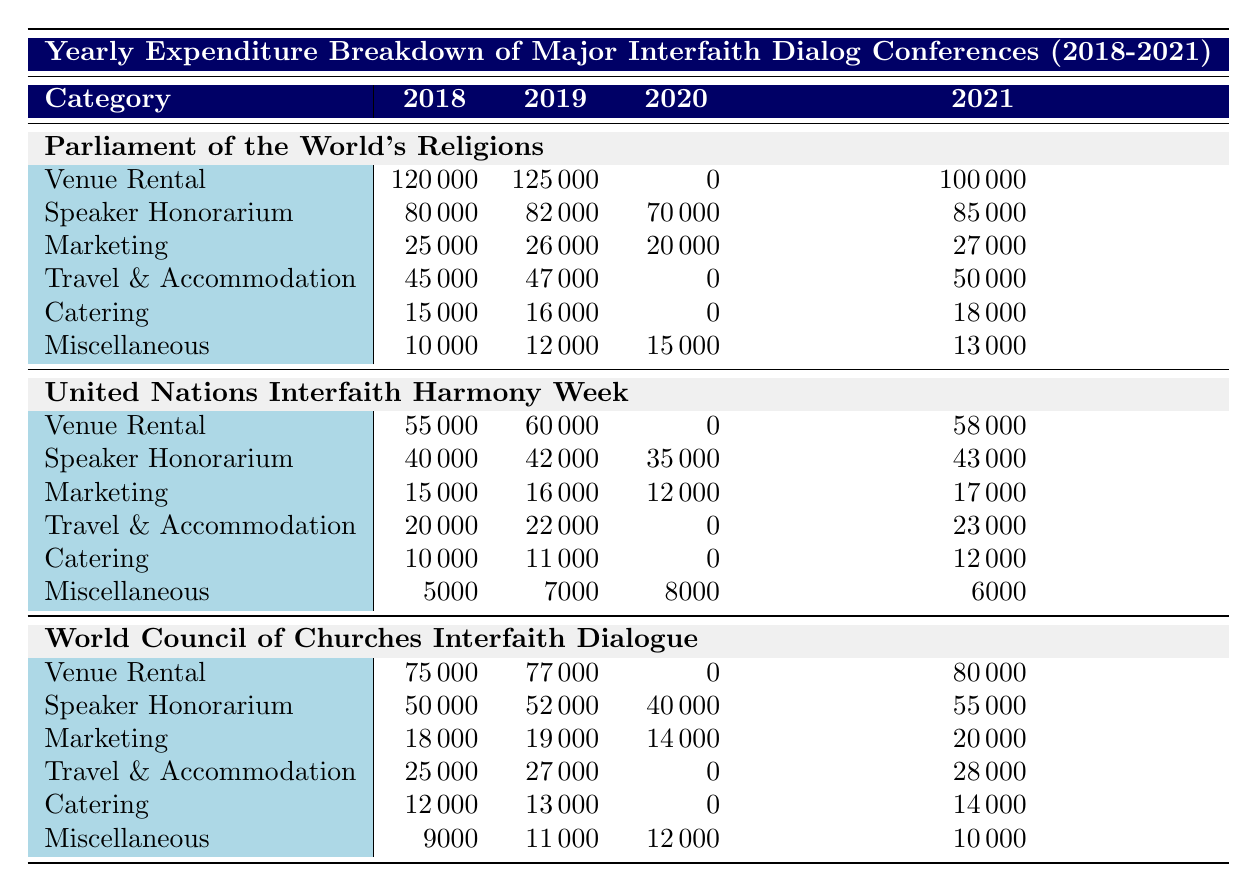What was the highest expenditure on Venue Rental in 2019? The table shows the Venue Rental expenditures for each conference in 2019. The values are 125000 for "Parliament of the World's Religions", 60000 for "United Nations Interfaith Harmony Week", and 77000 for "World Council of Churches Interfaith Dialogue". The highest value among these is 125000.
Answer: 125000 What is the total Catering expenditure for the "Parliament of the World's Religions" from 2018 to 2021? The table lists the Catering expenditures for "Parliament of the World's Religions" over the years: 15000 (2018) + 16000 (2019) + 0 (2020) + 18000 (2021). Summing these values gives: 15000 + 16000 + 0 + 18000 = 49000.
Answer: 49000 Did the "United Nations Interfaith Harmony Week" incur any expenses for Travel and Accommodation in 2020? The table indicates that the expenditure for Travel and Accommodation in 2020 for "United Nations Interfaith Harmony Week" is 0. Therefore, this specific category had no associated costs in that year.
Answer: No Which conference had the lowest Speaker Honorarium expense in 2020? The table presents the Speaker Honorarium expenditures for all conferences in 2020: 70000 for "Parliament of the World's Religions", 35000 for "United Nations Interfaith Harmony Week", and 40000 for "World Council of Churches Interfaith Dialogue". The lowest value is 35000, corresponding to "United Nations Interfaith Harmony Week".
Answer: United Nations Interfaith Harmony Week What was the increase in Marketing expenses from 2018 to 2021 for the "World Council of Churches Interfaith Dialogue"? For "World Council of Churches Interfaith Dialogue", the Marketing expenses are 18000 in 2018 and 20000 in 2021. The increase is calculated as: 20000 - 18000 = 2000.
Answer: 2000 